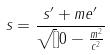Convert formula to latex. <formula><loc_0><loc_0><loc_500><loc_500>s = \frac { s ^ { \prime } + m e ^ { \prime } } { \sqrt { [ } ] { 0 - \frac { m ^ { 2 } } { c ^ { 2 } } } }</formula> 